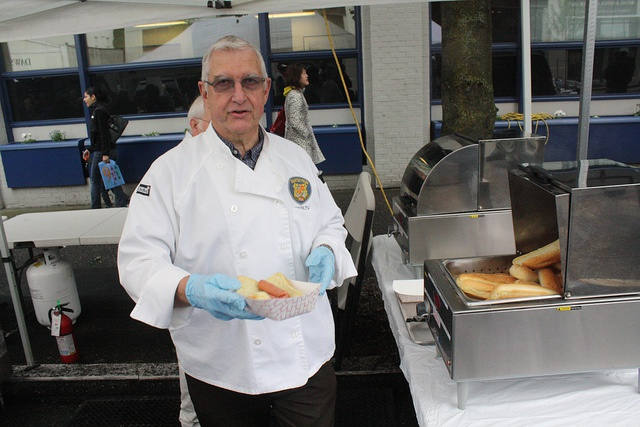Describe the objects in this image and their specific colors. I can see people in darkgray, lightgray, black, and brown tones, people in darkgray, black, gray, and navy tones, people in darkgray, gray, and black tones, hot dog in darkgray, tan, and white tones, and hot dog in darkgray, tan, brown, maroon, and black tones in this image. 